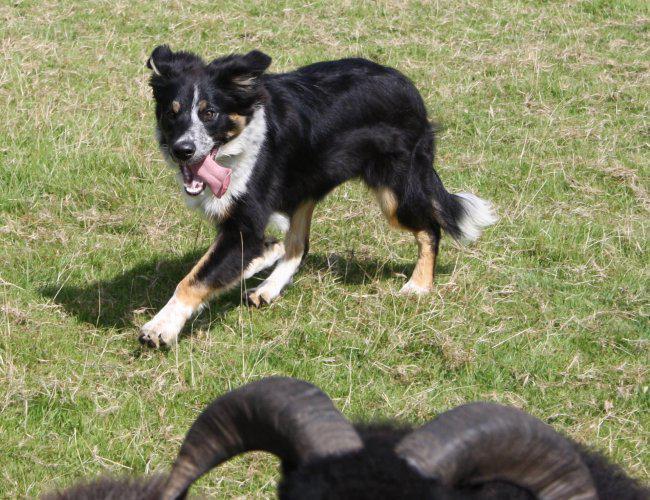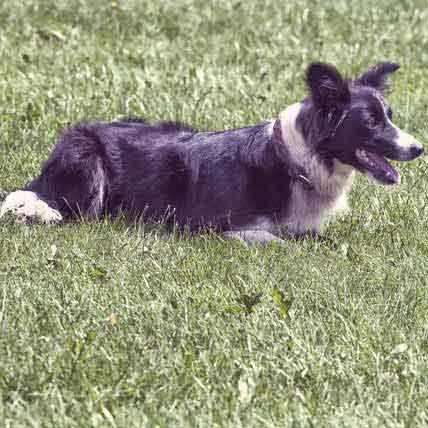The first image is the image on the left, the second image is the image on the right. Considering the images on both sides, is "The image on the left shows an Australian sheepdog herding 2 or 3 sheep or goats, and the one on the right shows an Australian sheepdog puppy on its own." valid? Answer yes or no. No. The first image is the image on the left, the second image is the image on the right. Examine the images to the left and right. Is the description "One image shows a black-and-white dog herding livestock, and the other shows one puppy in bright green grass near wildflowers." accurate? Answer yes or no. No. 